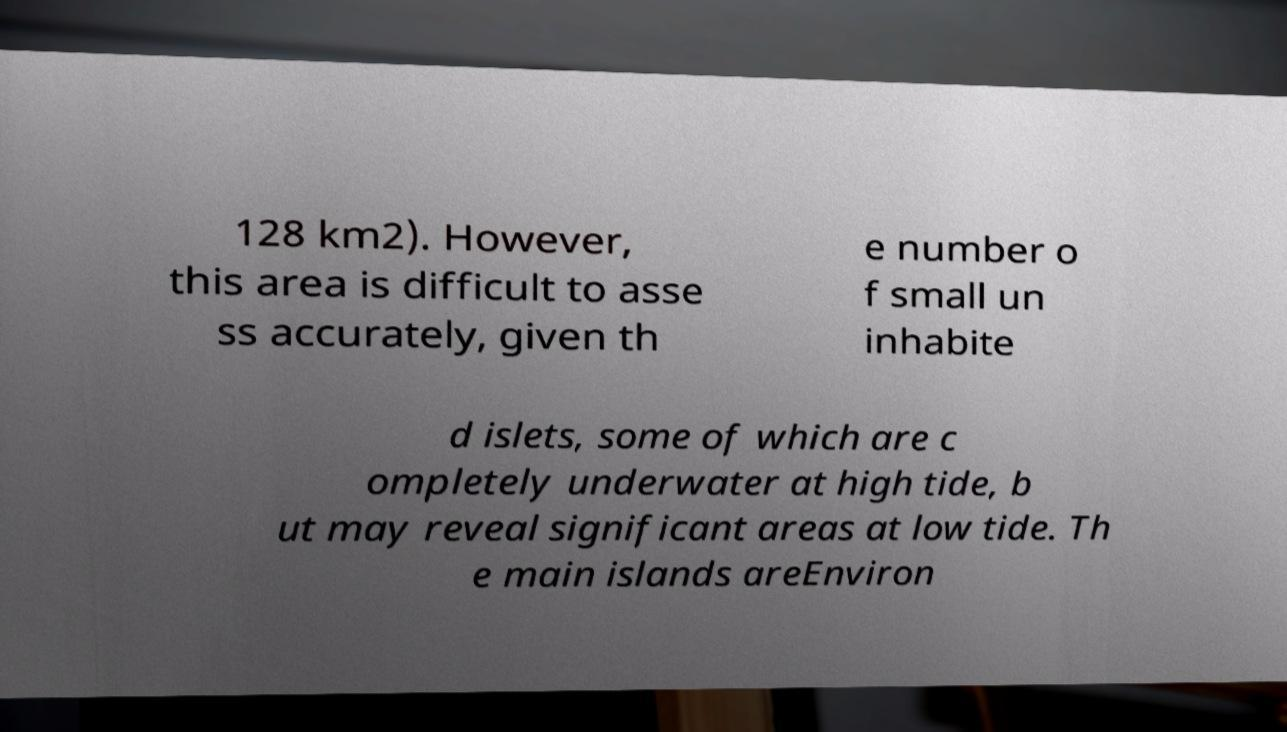For documentation purposes, I need the text within this image transcribed. Could you provide that? 128 km2). However, this area is difficult to asse ss accurately, given th e number o f small un inhabite d islets, some of which are c ompletely underwater at high tide, b ut may reveal significant areas at low tide. Th e main islands areEnviron 